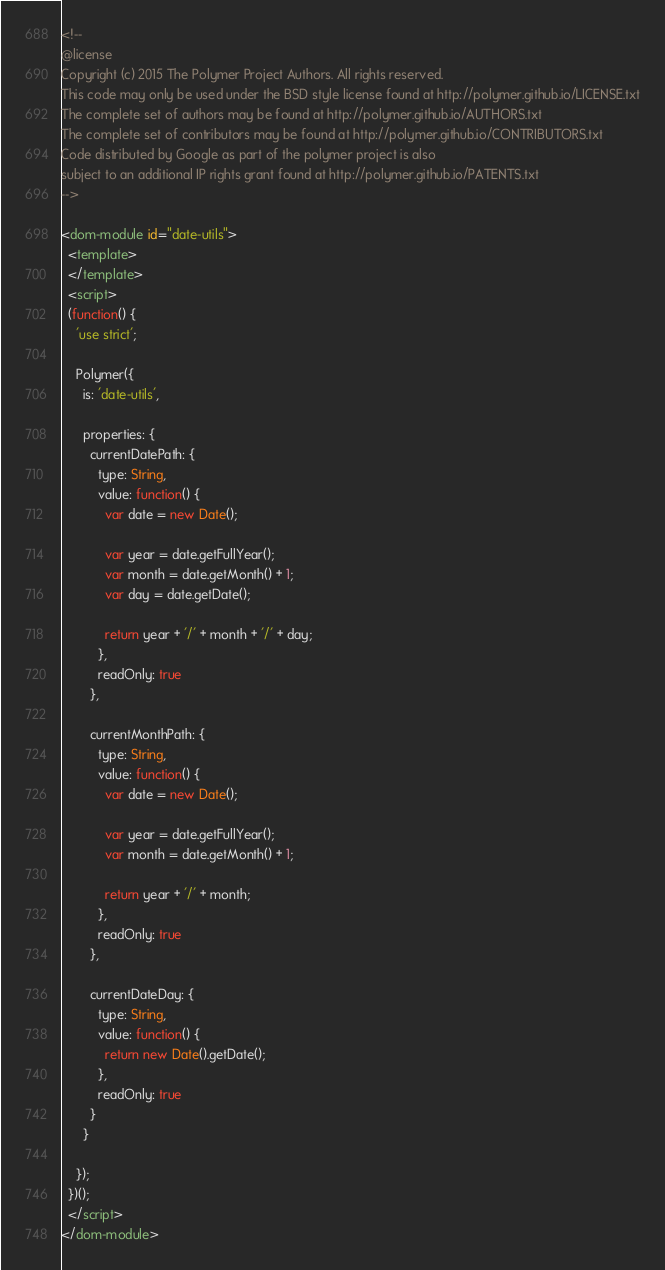Convert code to text. <code><loc_0><loc_0><loc_500><loc_500><_HTML_><!--
@license
Copyright (c) 2015 The Polymer Project Authors. All rights reserved.
This code may only be used under the BSD style license found at http://polymer.github.io/LICENSE.txt
The complete set of authors may be found at http://polymer.github.io/AUTHORS.txt
The complete set of contributors may be found at http://polymer.github.io/CONTRIBUTORS.txt
Code distributed by Google as part of the polymer project is also
subject to an additional IP rights grant found at http://polymer.github.io/PATENTS.txt
-->

<dom-module id="date-utils">
  <template>
  </template>
  <script>
  (function() {
    'use strict';

    Polymer({
      is: 'date-utils',

      properties: {
        currentDatePath: {
          type: String,
          value: function() {
            var date = new Date();
            
            var year = date.getFullYear();
            var month = date.getMonth() + 1;
            var day = date.getDate();

            return year + '/' + month + '/' + day;
          },
          readOnly: true
        },

        currentMonthPath: {
          type: String,
          value: function() {
            var date = new Date();
            
            var year = date.getFullYear();
            var month = date.getMonth() + 1;

            return year + '/' + month;
          },
          readOnly: true
        },

        currentDateDay: {
          type: String,
          value: function() {
            return new Date().getDate();
          },
          readOnly: true
        }
      }

    });
  })();
  </script>
</dom-module>
</code> 